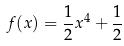<formula> <loc_0><loc_0><loc_500><loc_500>f ( x ) = \frac { 1 } { 2 } x ^ { 4 } + \frac { 1 } { 2 }</formula> 